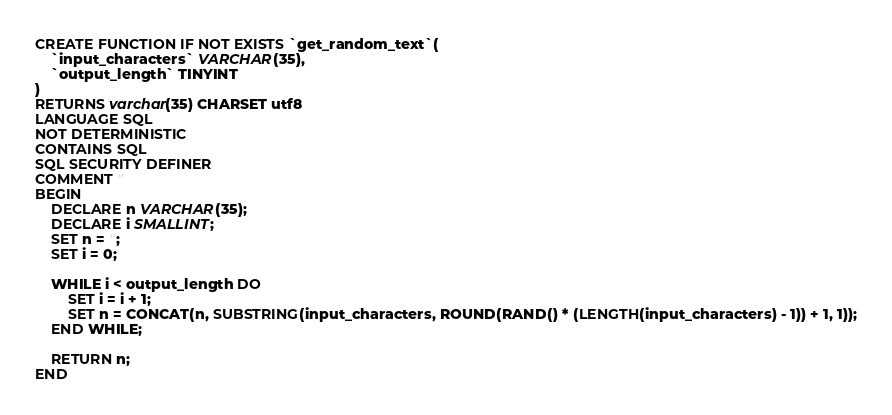<code> <loc_0><loc_0><loc_500><loc_500><_SQL_>CREATE FUNCTION IF NOT EXISTS `get_random_text`(
	`input_characters` VARCHAR(35),
	`output_length` TINYINT
)
RETURNS varchar(35) CHARSET utf8
LANGUAGE SQL
NOT DETERMINISTIC
CONTAINS SQL
SQL SECURITY DEFINER
COMMENT ''
BEGIN
	DECLARE n VARCHAR(35);
	DECLARE i SMALLINT;
	SET n = '';
	SET i = 0;
	
	WHILE i < output_length DO
		SET i = i + 1;
		SET n = CONCAT(n, SUBSTRING(input_characters, ROUND(RAND() * (LENGTH(input_characters) - 1)) + 1, 1));
	END WHILE;

	RETURN n;
END</code> 